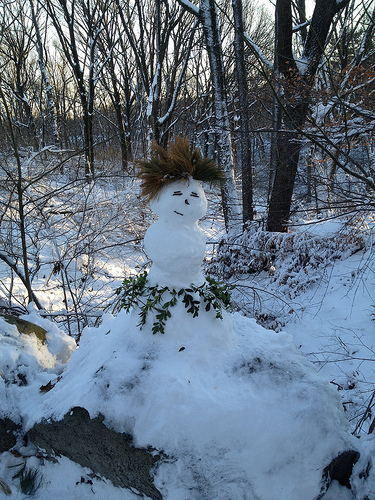<image>
Can you confirm if the head is on the ice? Yes. Looking at the image, I can see the head is positioned on top of the ice, with the ice providing support. Where is the snowman in relation to the tree? Is it under the tree? Yes. The snowman is positioned underneath the tree, with the tree above it in the vertical space. 